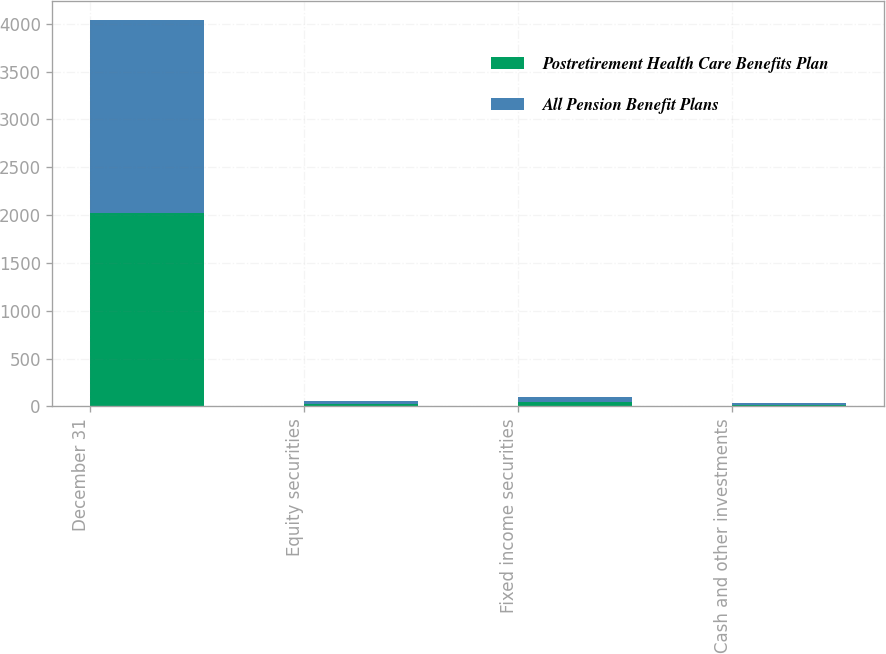Convert chart to OTSL. <chart><loc_0><loc_0><loc_500><loc_500><stacked_bar_chart><ecel><fcel>December 31<fcel>Equity securities<fcel>Fixed income securities<fcel>Cash and other investments<nl><fcel>Postretirement Health Care Benefits Plan<fcel>2018<fcel>30<fcel>51<fcel>19<nl><fcel>All Pension Benefit Plans<fcel>2018<fcel>32<fcel>49<fcel>19<nl></chart> 